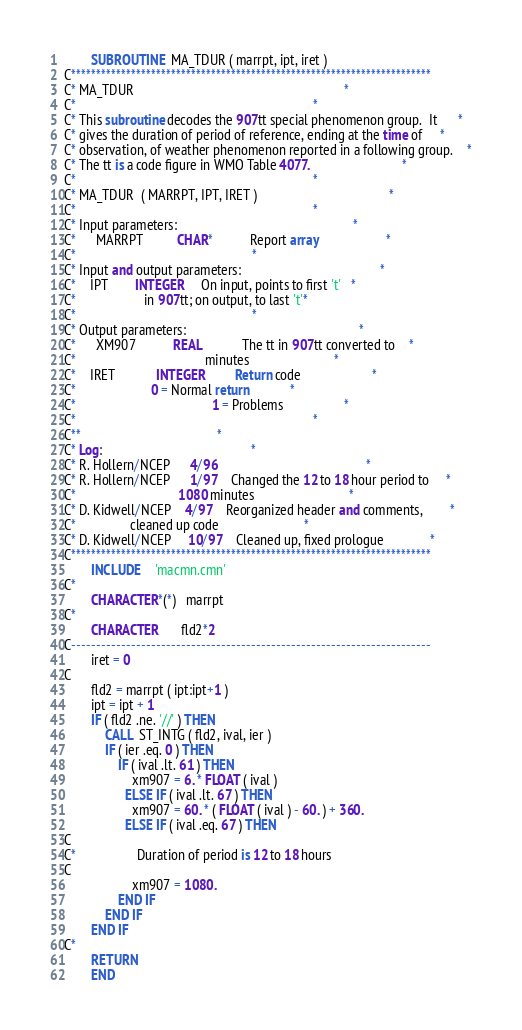Convert code to text. <code><loc_0><loc_0><loc_500><loc_500><_FORTRAN_>        SUBROUTINE  MA_TDUR ( marrpt, ipt, iret )
C************************************************************************
C* MA_TDUR                                                              *
C*                                                                      *
C* This subroutine decodes the 907tt special phenomenon group.  It      *
C* gives the duration of period of reference, ending at the time of     *
C* observation, of weather phenomenon reported in a following group.    *
C* The tt is a code figure in WMO Table 4077.                           *
C*                                                                      *
C* MA_TDUR  ( MARRPT, IPT, IRET )                                       *
C*                                                                      *
C* Input parameters:                                                    *
C*      MARRPT          CHAR*           Report array                    *
C*					                                *
C* Input and output parameters:                                         *
C*	IPT		INTEGER		On input, points to first 't'   *
C*					in 907tt; on output, to last 't'*
C*					                                *
C* Output parameters:                                                   *
C*      XM907           REAL            The tt in 907tt converted to    *
C*                                      minutes                         *
C*	IRET            INTEGER         Return code                     *
C*				   	  0 = Normal return 	        *
C*                                        1 = Problems                  *
C*                                                                      *
C**								        *
C* Log:							                *
C* R. Hollern/NCEP      4/96                                            *
C* R. Hollern/NCEP      1/97    Changed the 12 to 18 hour period to     *
C*                              1080 minutes                            *
C* D. Kidwell/NCEP	4/97	Reorganized header and comments,        *
C*				cleaned up code                         *
C* D. Kidwell/NCEP     10/97	Cleaned up, fixed prologue              *
C************************************************************************
        INCLUDE  	'macmn.cmn'
C*
        CHARACTER*(*)   marrpt
C*
        CHARACTER      	fld2*2
C------------------------------------------------------------------------
        iret = 0
C
        fld2 = marrpt ( ipt:ipt+1 )
        ipt = ipt + 1
        IF ( fld2 .ne. '//' ) THEN
            CALL  ST_INTG ( fld2, ival, ier )
            IF ( ier .eq. 0 ) THEN
                IF ( ival .lt. 61 ) THEN
                    xm907 = 6. * FLOAT ( ival )
                  ELSE IF ( ival .lt. 67 ) THEN
                    xm907 = 60. * ( FLOAT ( ival ) - 60. ) + 360.
                  ELSE IF ( ival .eq. 67 ) THEN
C
C*                  Duration of period is 12 to 18 hours
C
                    xm907 = 1080.
                END IF
            END IF
        END IF
C*
        RETURN
        END
</code> 